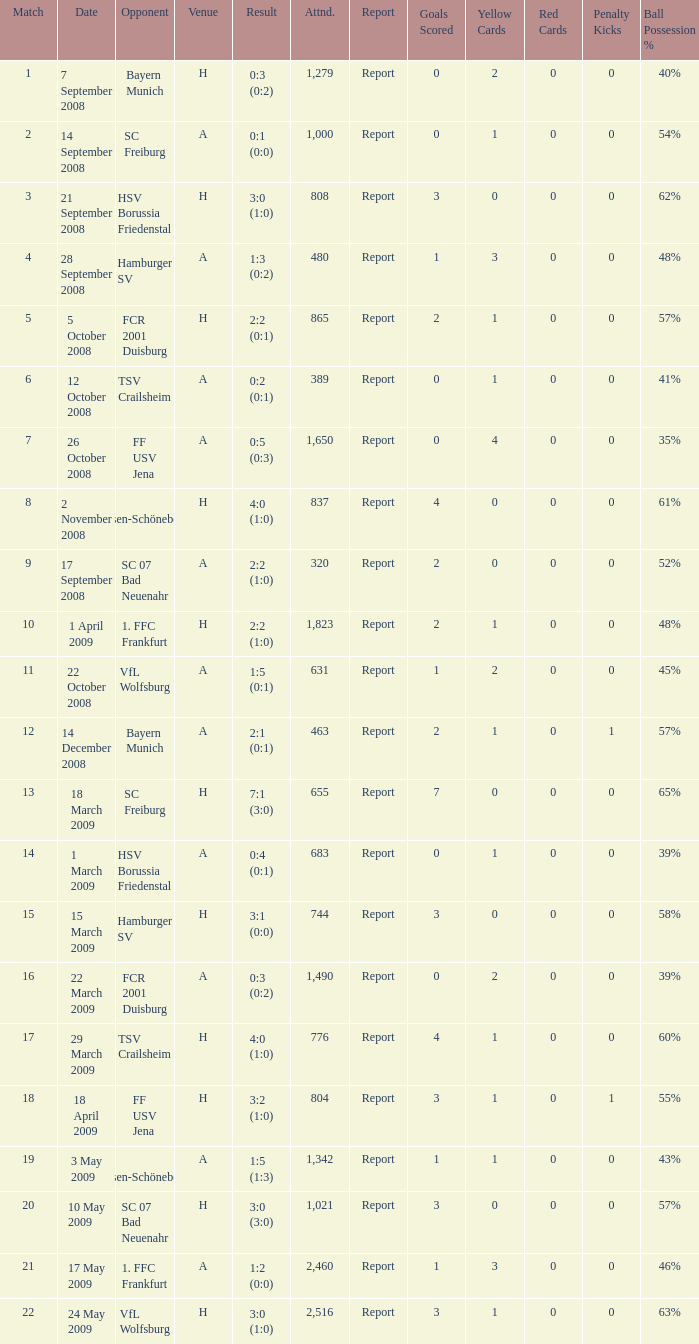What is the match number that had a result of 0:5 (0:3)? 1.0. 